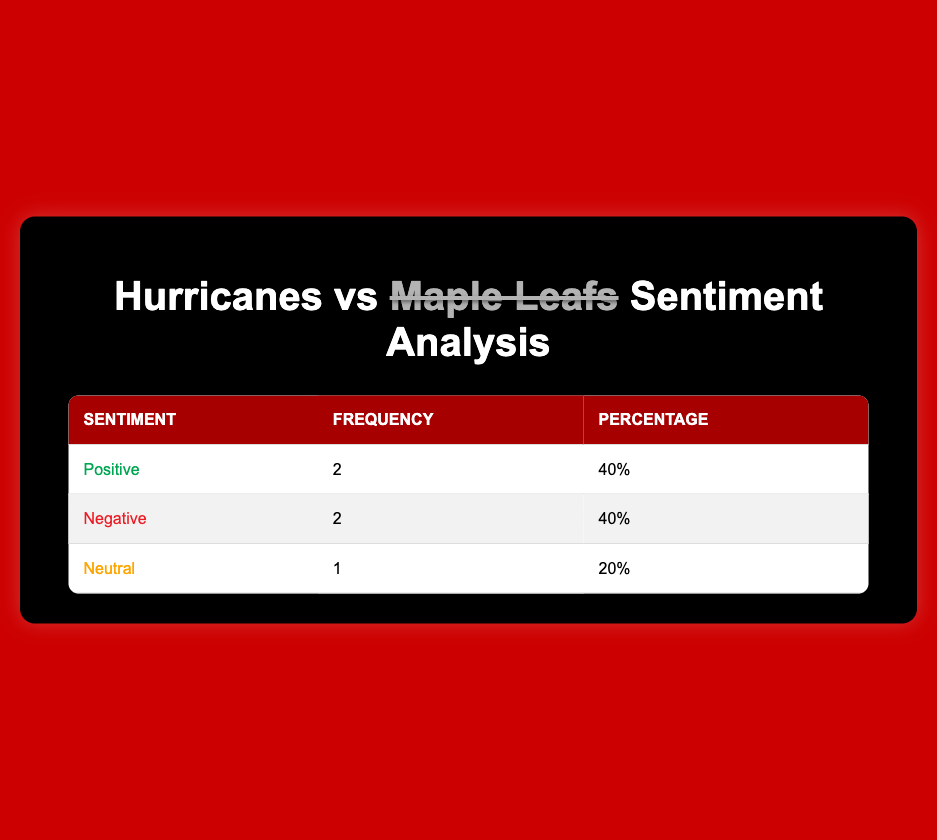What is the frequency of positive sentiment recorded in the matchups? The table shows that the frequency of positive sentiment is listed as 2. This can be found directly in the rows of the table under the sentiment category.
Answer: 2 How many total matchups were analyzed for sentiment? The total number of matchups represented in the table is 5. This is determined by counting each row of the data.
Answer: 5 What percentage of the sentiments recorded were negative? Negative sentiments constitute 40% of the total sentiments recorded. This information is directly displayed in the table under the percentage column for negative sentiment.
Answer: 40% What is the difference between the frequency of positive and negative sentiments? The frequency of positive sentiment is 2, and the negative sentiment is also 2. To find the difference, you subtract 2 from 2, which equals 0.
Answer: 0 Is there a matchup with a neutral sentiment? Yes, there is one matchup recorded with neutral sentiment. This is evident from the table where the neutral sentiment appears in one row.
Answer: Yes Which sentiment has the highest frequency in the matchups? Both positive and negative sentiments have the same frequency of 2. Since they are equal, either can be considered the highest frequency sentiment. This is noted in the frequency column where both sentiments match.
Answer: Positive and Negative What is the ratio of positive to neutral sentiments in the table? The frequency of positive sentiment is 2 and the frequency of neutral sentiment is 1. To get the ratio, you divide 2 by 1, resulting in a ratio of 2:1.
Answer: 2:1 Which sentiment had more occurrences, positive or neutral? Positive sentiment occurred 2 times while neutral sentiment occurred only once. This can be verified by checking the frequency counts in the table.
Answer: Positive If we were to categorize sentiments as either favorable (positive) or unfavorable (negative), what percentage of sentiments falls under unfavorable? Both negative sentiments are considered unfavorable. Since there are 2 negative sentiments out of a total of 5, the percentage is calculated as (2/5) * 100 = 40%.
Answer: 40% 